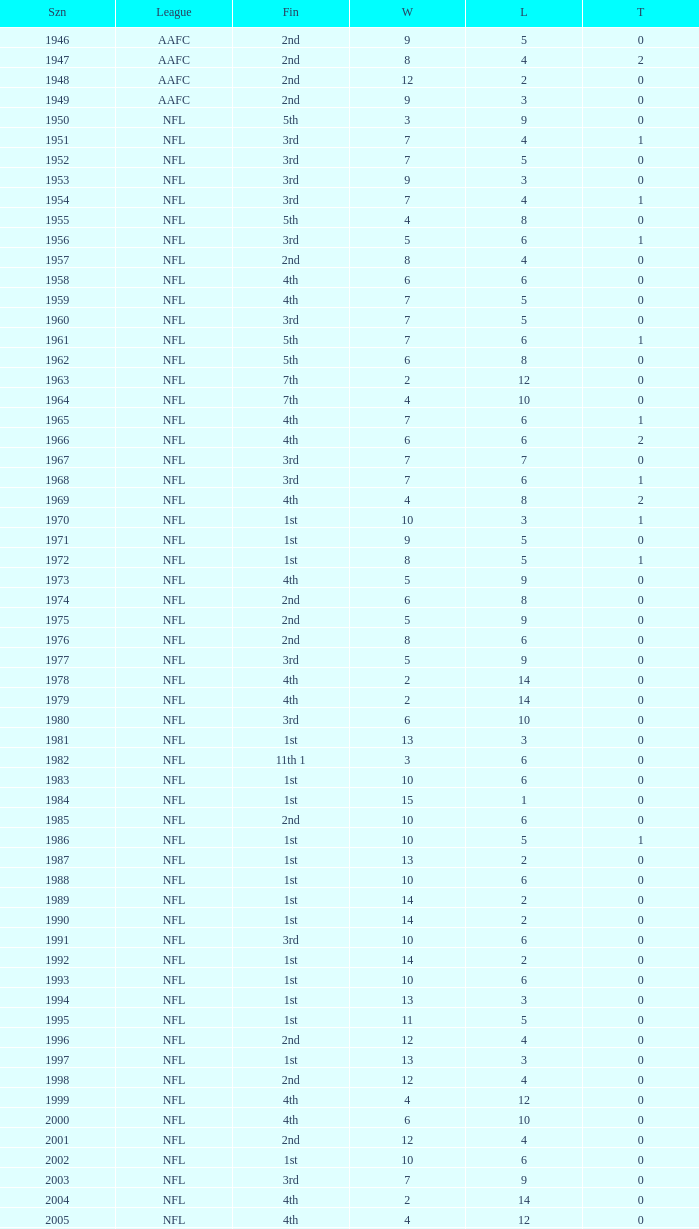What is the lowest number of ties in the NFL, with less than 2 losses and less than 15 wins? None. 